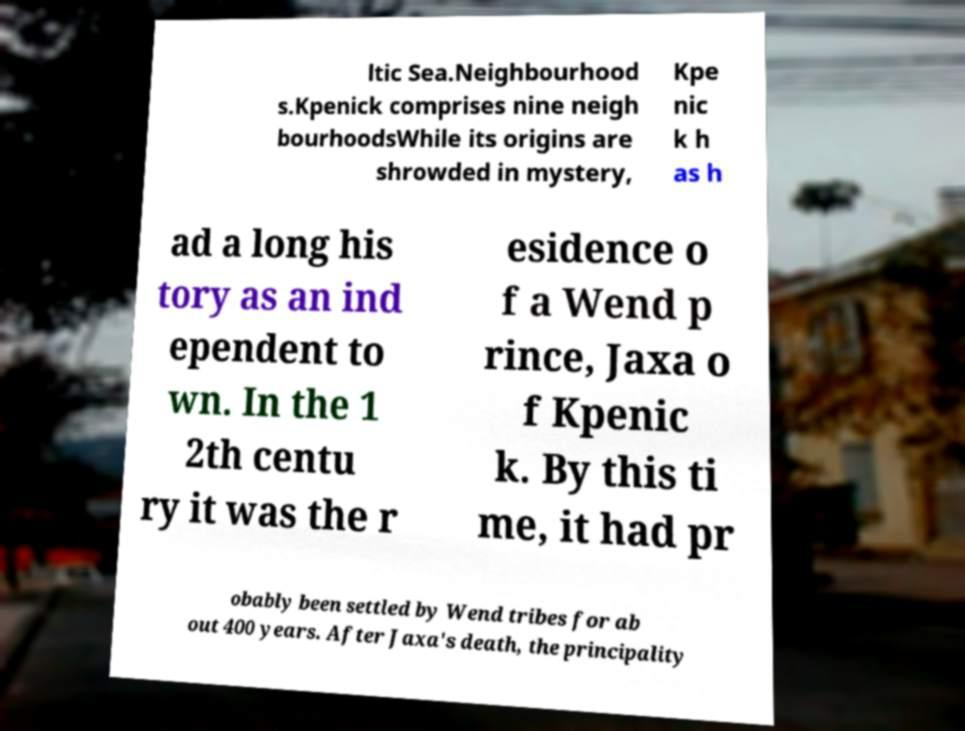I need the written content from this picture converted into text. Can you do that? ltic Sea.Neighbourhood s.Kpenick comprises nine neigh bourhoodsWhile its origins are shrowded in mystery, Kpe nic k h as h ad a long his tory as an ind ependent to wn. In the 1 2th centu ry it was the r esidence o f a Wend p rince, Jaxa o f Kpenic k. By this ti me, it had pr obably been settled by Wend tribes for ab out 400 years. After Jaxa's death, the principality 